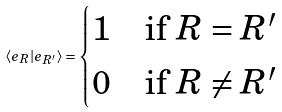<formula> <loc_0><loc_0><loc_500><loc_500>\langle e _ { R } | e _ { R ^ { \prime } } \rangle = \begin{cases} 1 & \text {if $R=R^{\prime}$} \\ 0 & \text {if $R\ne R^{\prime}$} \end{cases}</formula> 